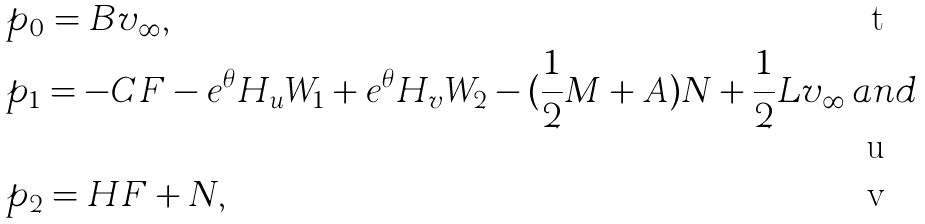<formula> <loc_0><loc_0><loc_500><loc_500>& p _ { 0 } = B v _ { \infty } , \\ & p _ { 1 } = - C F - e ^ { \theta } H _ { u } W _ { 1 } + e ^ { \theta } H _ { v } W _ { 2 } - ( \frac { 1 } { 2 } M + A ) N + \frac { 1 } { 2 } L v _ { \infty } \, a n d \\ & p _ { 2 } = H F + N ,</formula> 